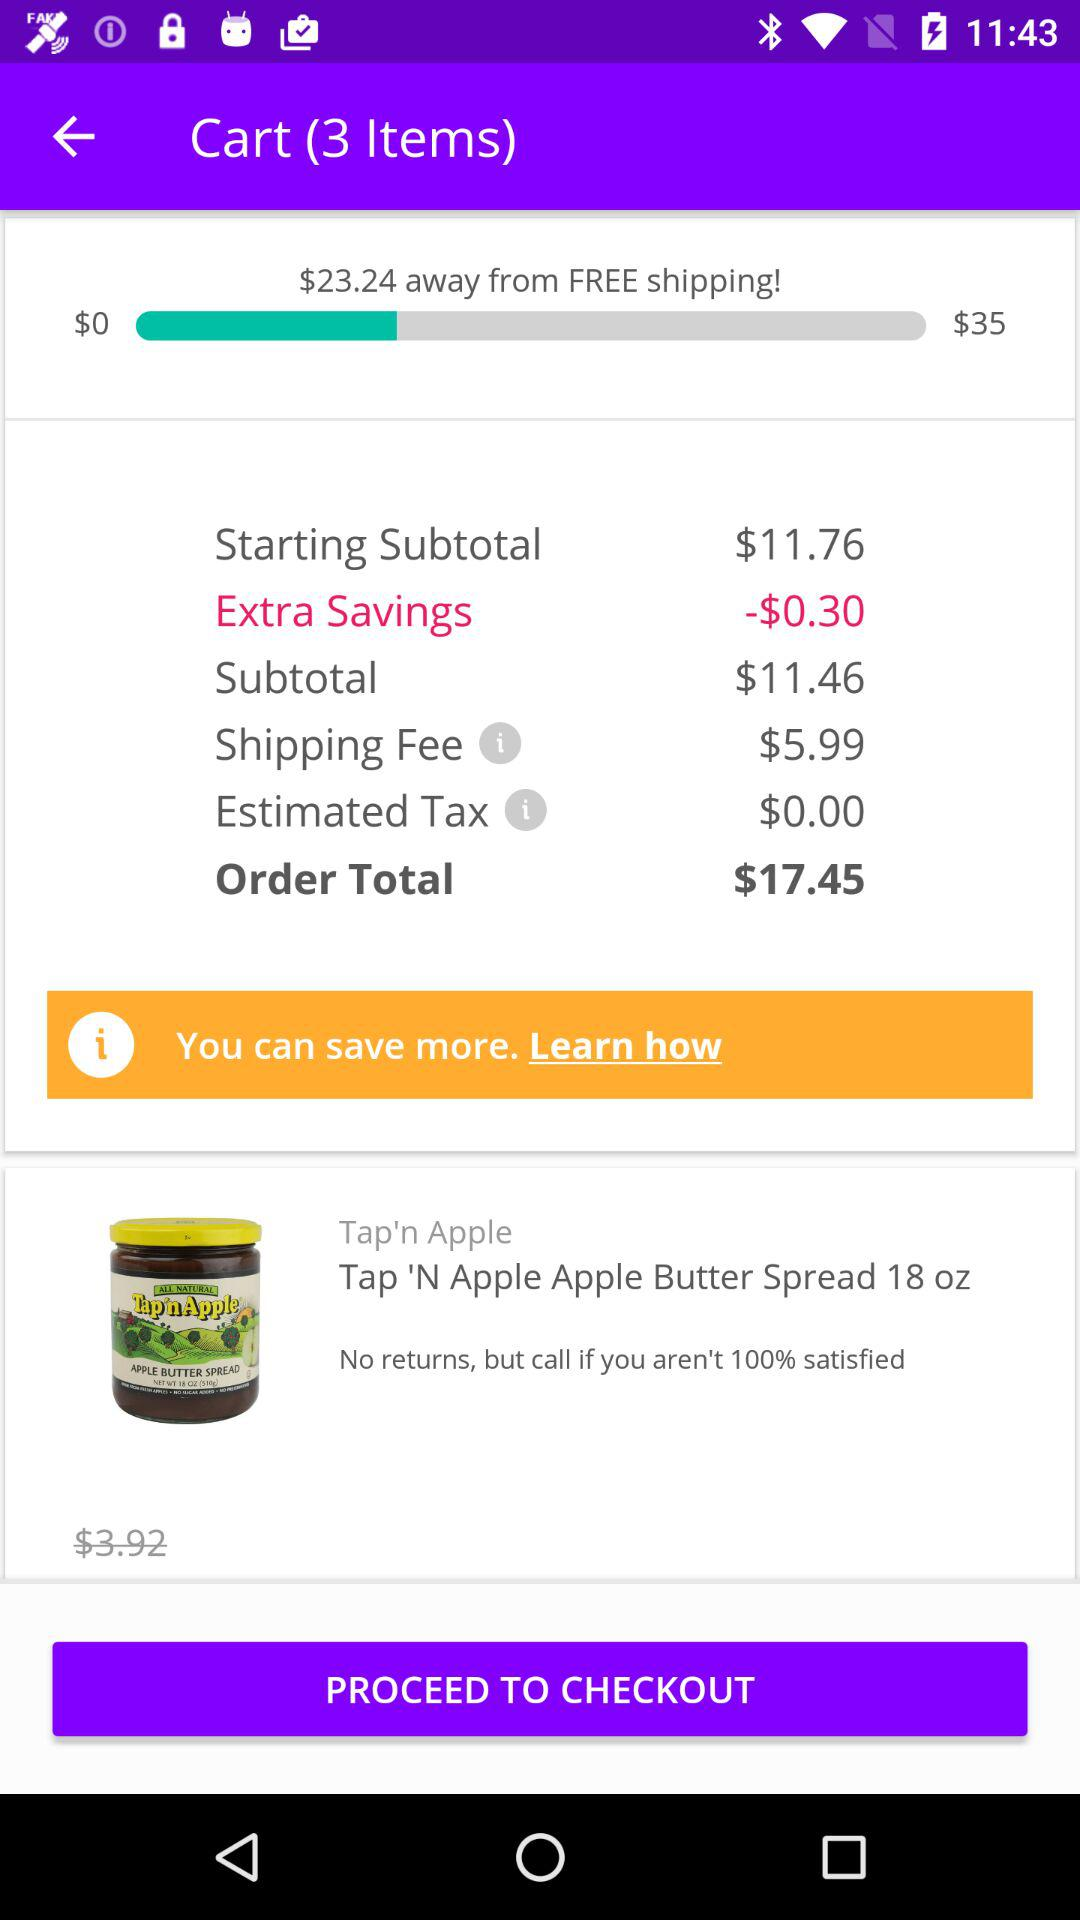What is the name of the item whose price is $3.92? The name of the item whose price is $3.92 is "Tap 'N Apple Apple Butter Spread 18 oz". 